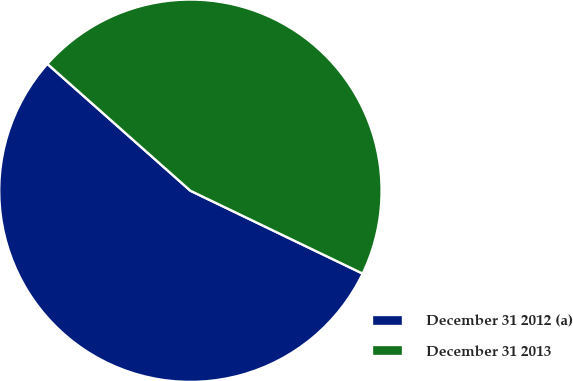Convert chart to OTSL. <chart><loc_0><loc_0><loc_500><loc_500><pie_chart><fcel>December 31 2012 (a)<fcel>December 31 2013<nl><fcel>54.41%<fcel>45.59%<nl></chart> 